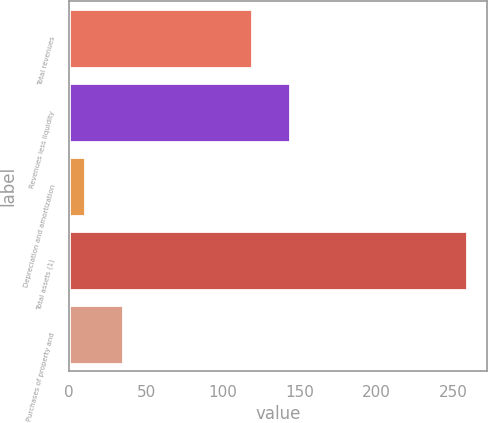Convert chart. <chart><loc_0><loc_0><loc_500><loc_500><bar_chart><fcel>Total revenues<fcel>Revenues less liquidity<fcel>Depreciation and amortization<fcel>Total assets (1)<fcel>Purchases of property and<nl><fcel>119<fcel>143.9<fcel>10<fcel>259<fcel>34.9<nl></chart> 